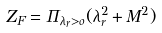Convert formula to latex. <formula><loc_0><loc_0><loc_500><loc_500>Z _ { F } = \Pi _ { \lambda _ { r } > o } ( \lambda _ { r } ^ { 2 } + M ^ { 2 } )</formula> 